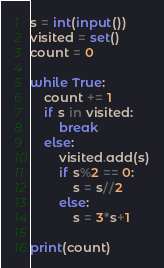Convert code to text. <code><loc_0><loc_0><loc_500><loc_500><_Python_>s = int(input())
visited = set()
count = 0

while True:
    count += 1
    if s in visited:
        break
    else:
        visited.add(s)
        if s%2 == 0:
            s = s//2
        else:
            s = 3*s+1

print(count)</code> 